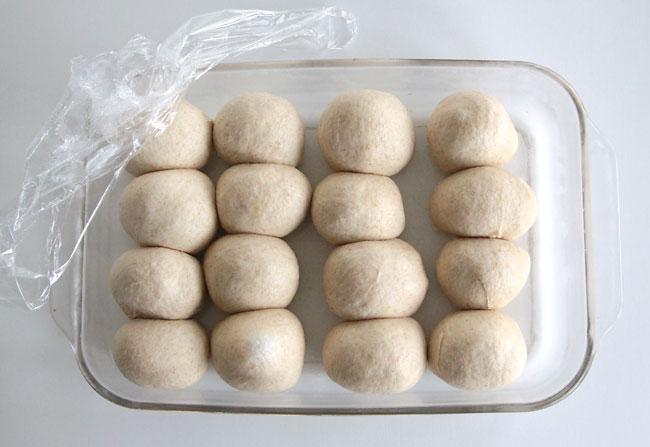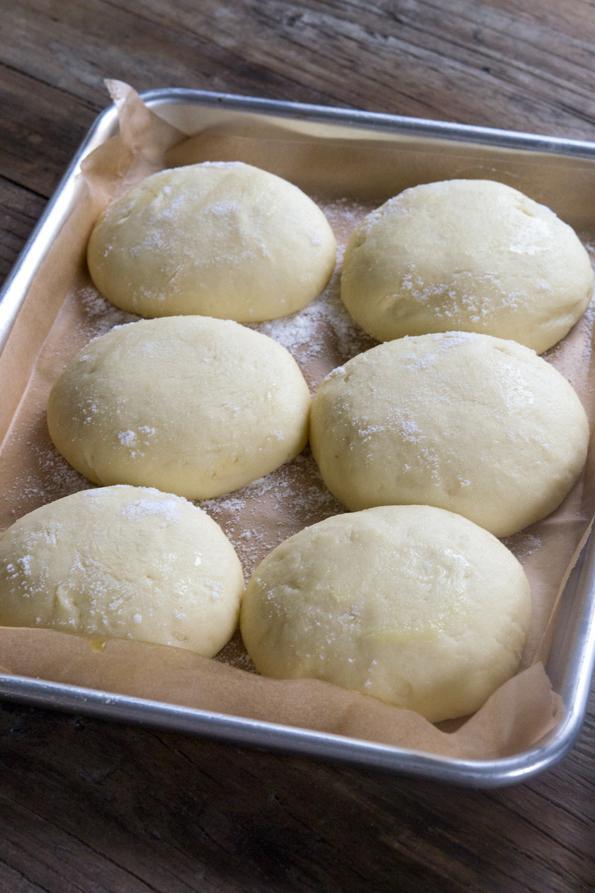The first image is the image on the left, the second image is the image on the right. Examine the images to the left and right. Is the description "there are 6 balls of bread dough in a silver pan lined with parchment paper" accurate? Answer yes or no. Yes. The first image is the image on the left, the second image is the image on the right. Examine the images to the left and right. Is the description "One pan of dough has at least sixteen balls, and all pans have balls that are touching and not spaced out." accurate? Answer yes or no. Yes. 